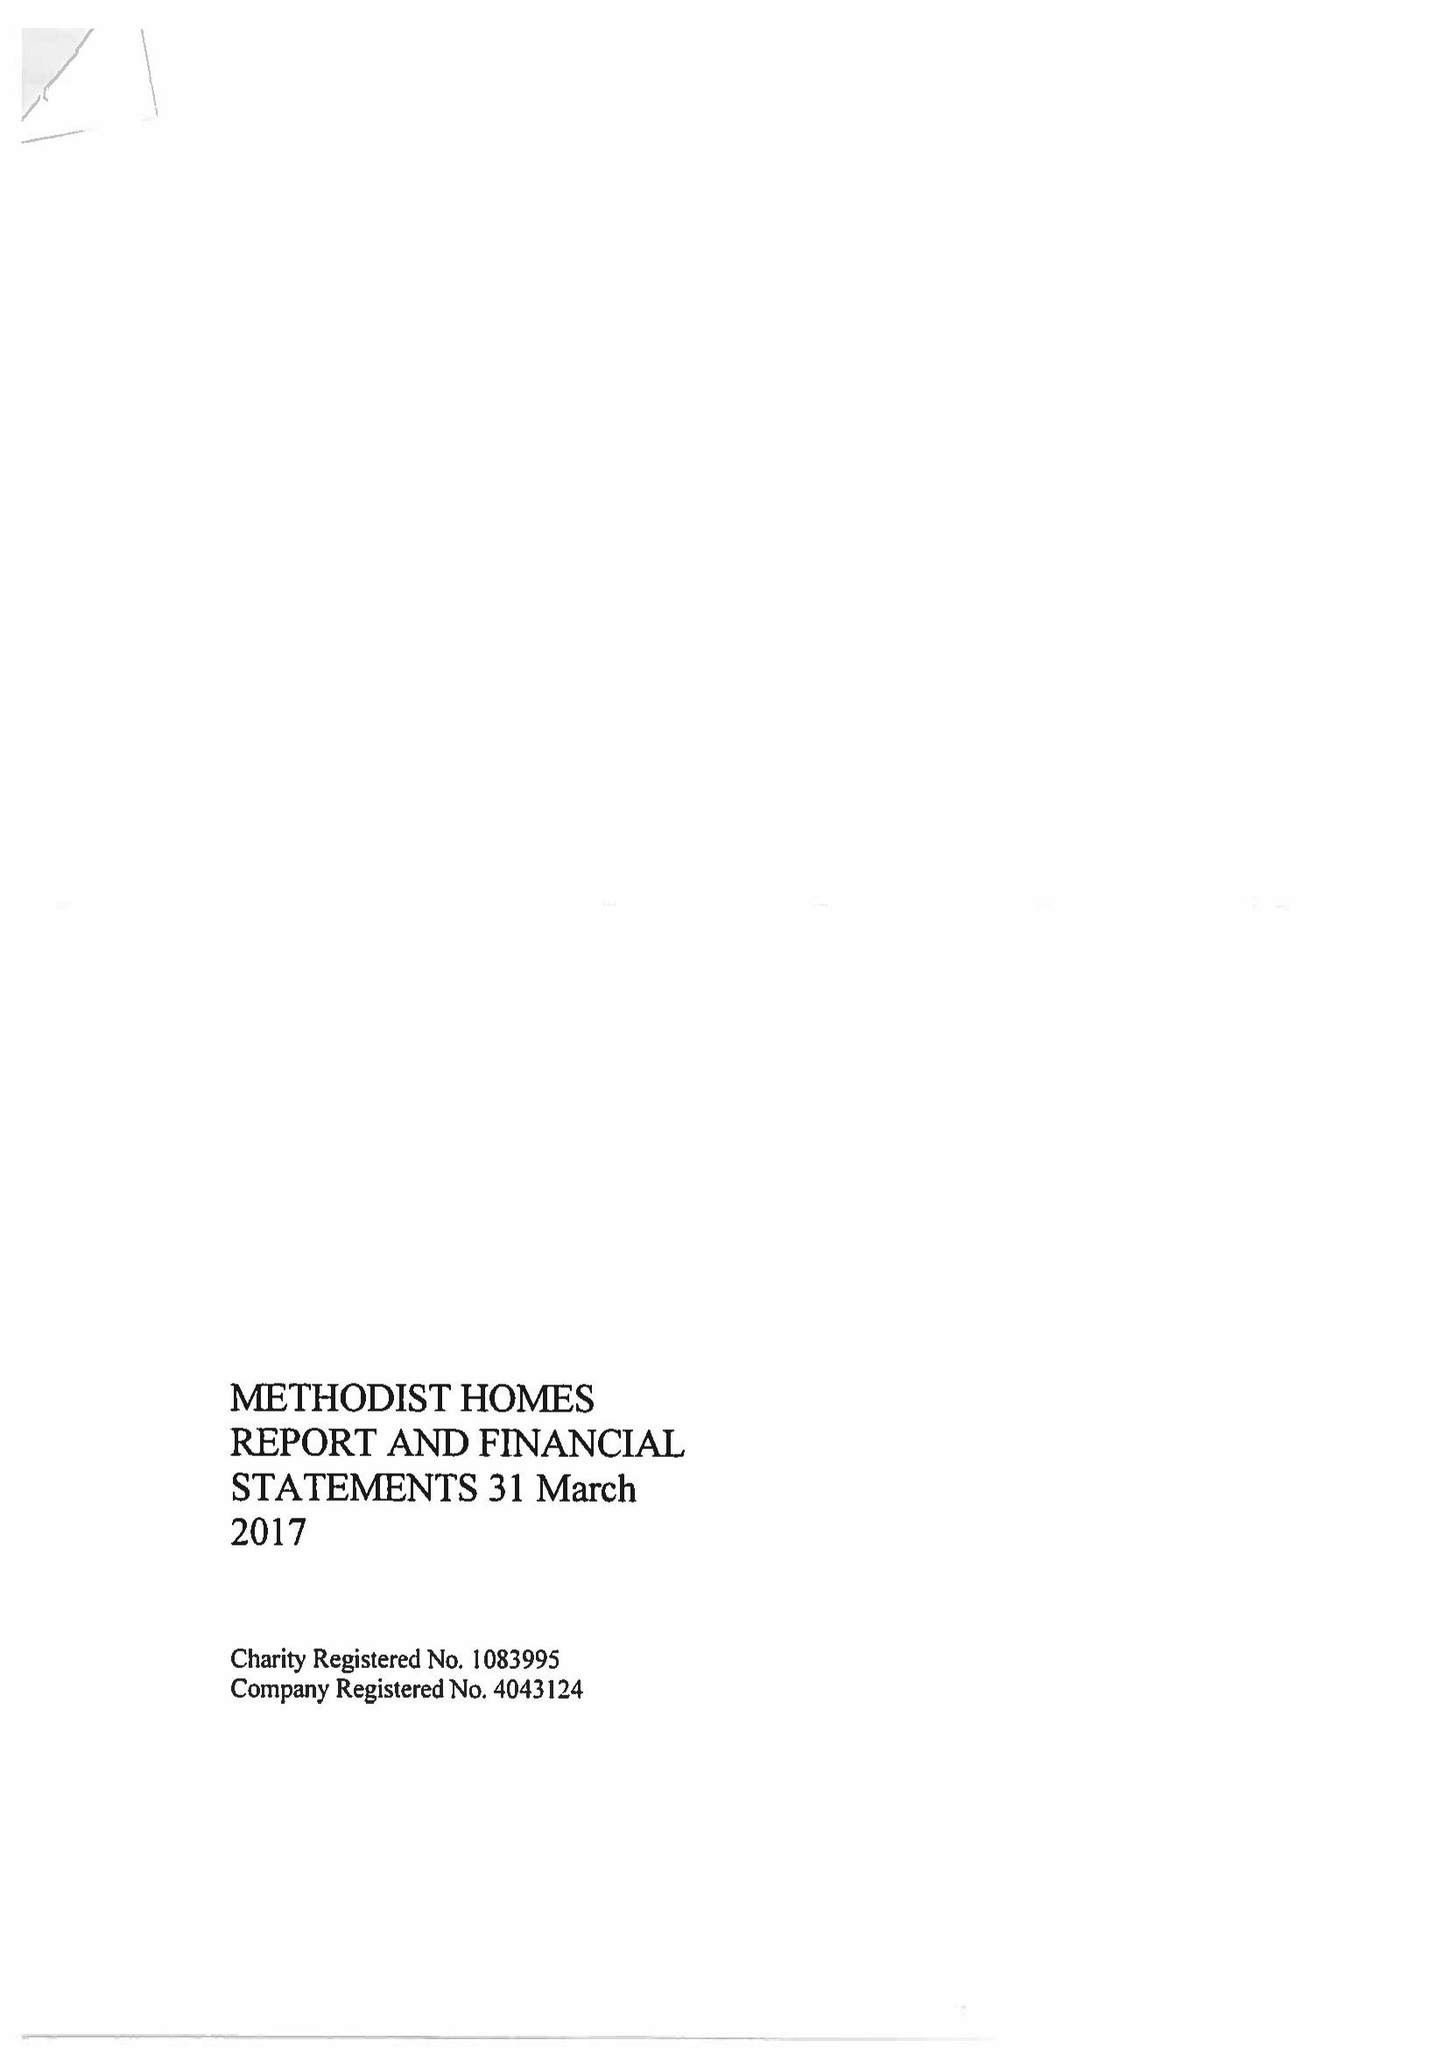What is the value for the report_date?
Answer the question using a single word or phrase. 2017-03-31 